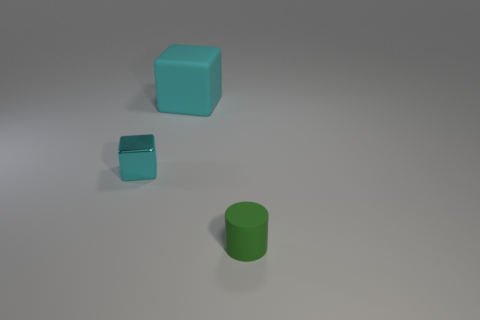Subtract all cyan cubes. How many were subtracted if there are1cyan cubes left? 1 Subtract all cylinders. How many objects are left? 2 Subtract 2 blocks. How many blocks are left? 0 Subtract 1 cyan cubes. How many objects are left? 2 Subtract all yellow blocks. Subtract all brown cylinders. How many blocks are left? 2 Subtract all gray cubes. How many blue cylinders are left? 0 Subtract all large yellow rubber blocks. Subtract all tiny cyan shiny objects. How many objects are left? 2 Add 2 small cylinders. How many small cylinders are left? 3 Add 1 big brown rubber blocks. How many big brown rubber blocks exist? 1 Add 2 small metal blocks. How many objects exist? 5 